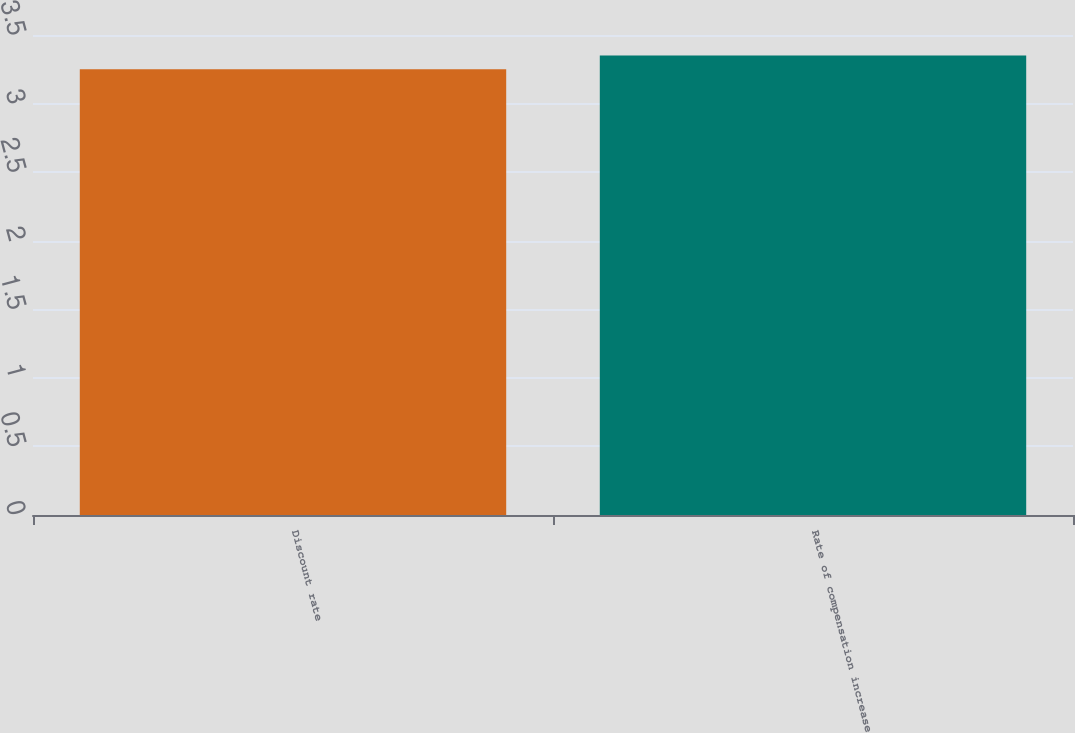Convert chart to OTSL. <chart><loc_0><loc_0><loc_500><loc_500><bar_chart><fcel>Discount rate<fcel>Rate of compensation increase<nl><fcel>3.25<fcel>3.35<nl></chart> 